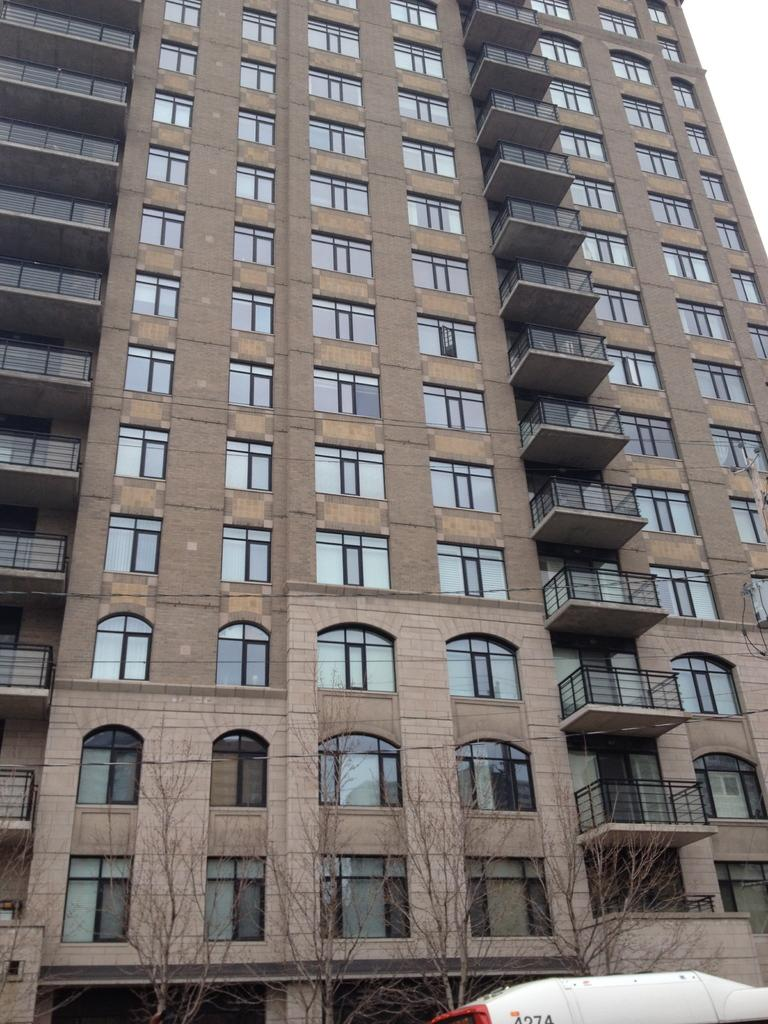What type of structure is visible in the image? There is a building in the image. What can be seen in the background of the image? There are trees in the image. What feature of the building is visible in the image? There are windows in the image. What type of architectural element is present in the image? There is a grille in the image. What else is present in the image besides the building? There is a vehicle in the image. How many frogs are sitting on the vehicle in the image? There are no frogs present in the image, so it is not possible to determine how many might be sitting on the vehicle. 